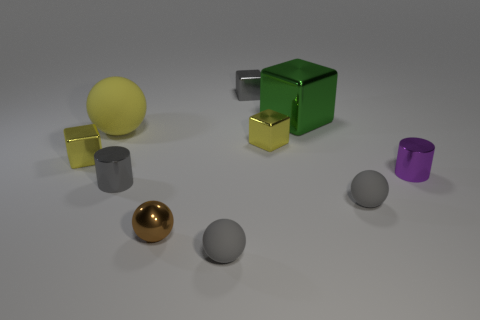Subtract 1 balls. How many balls are left? 3 Subtract all cylinders. How many objects are left? 8 Subtract 1 yellow spheres. How many objects are left? 9 Subtract all blue shiny objects. Subtract all brown objects. How many objects are left? 9 Add 2 large yellow rubber spheres. How many large yellow rubber spheres are left? 3 Add 5 large blue rubber balls. How many large blue rubber balls exist? 5 